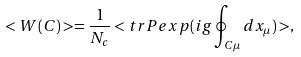Convert formula to latex. <formula><loc_0><loc_0><loc_500><loc_500>< W ( C ) > = \frac { 1 } { N _ { c } } < t r P e x p ( i g \oint _ { C \mu } d x _ { \mu } ) > ,</formula> 